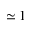<formula> <loc_0><loc_0><loc_500><loc_500>\simeq 1</formula> 